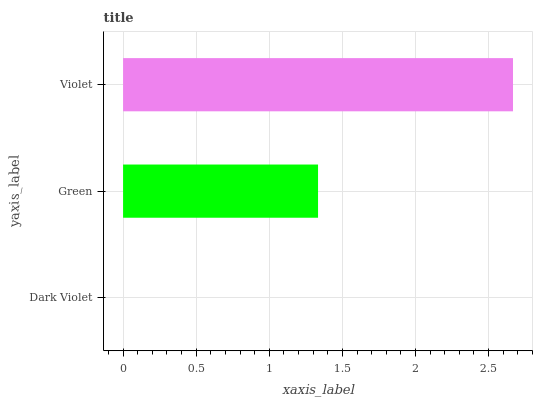Is Dark Violet the minimum?
Answer yes or no. Yes. Is Violet the maximum?
Answer yes or no. Yes. Is Green the minimum?
Answer yes or no. No. Is Green the maximum?
Answer yes or no. No. Is Green greater than Dark Violet?
Answer yes or no. Yes. Is Dark Violet less than Green?
Answer yes or no. Yes. Is Dark Violet greater than Green?
Answer yes or no. No. Is Green less than Dark Violet?
Answer yes or no. No. Is Green the high median?
Answer yes or no. Yes. Is Green the low median?
Answer yes or no. Yes. Is Violet the high median?
Answer yes or no. No. Is Violet the low median?
Answer yes or no. No. 